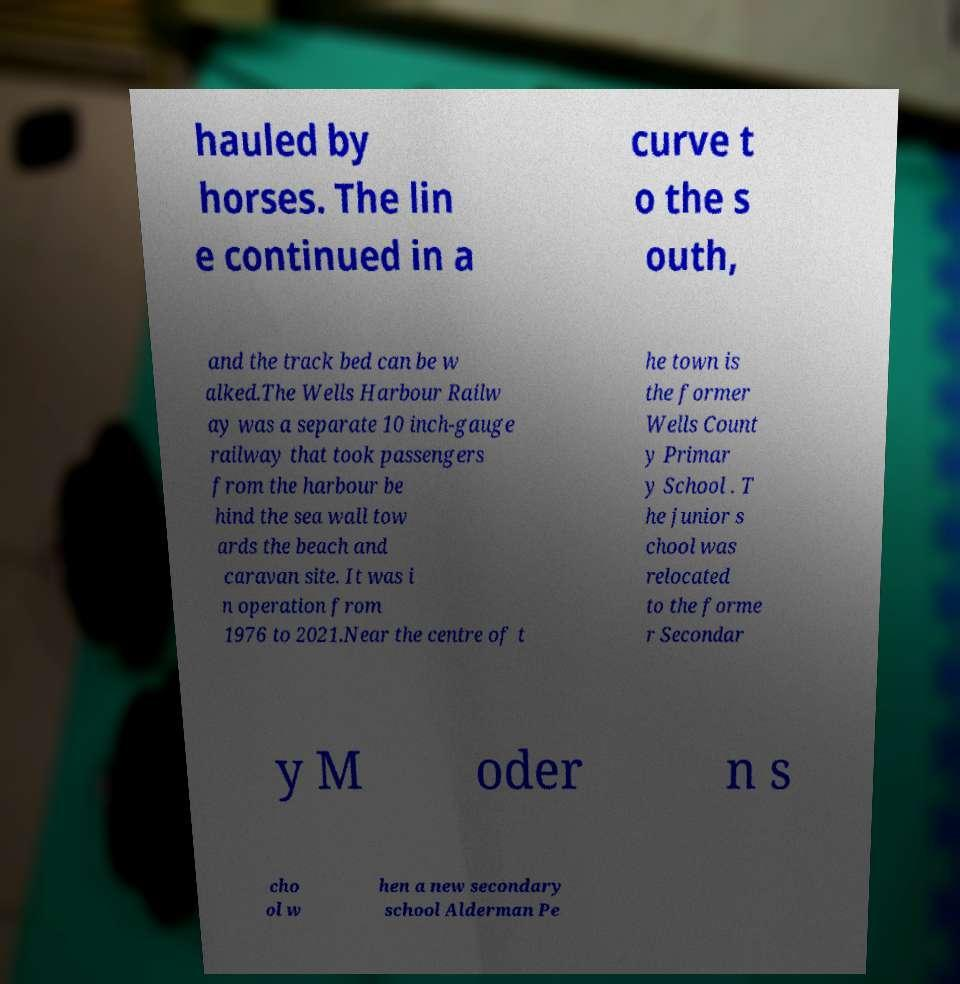Can you accurately transcribe the text from the provided image for me? hauled by horses. The lin e continued in a curve t o the s outh, and the track bed can be w alked.The Wells Harbour Railw ay was a separate 10 inch-gauge railway that took passengers from the harbour be hind the sea wall tow ards the beach and caravan site. It was i n operation from 1976 to 2021.Near the centre of t he town is the former Wells Count y Primar y School . T he junior s chool was relocated to the forme r Secondar y M oder n s cho ol w hen a new secondary school Alderman Pe 